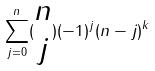Convert formula to latex. <formula><loc_0><loc_0><loc_500><loc_500>\sum _ { j = 0 } ^ { n } ( \begin{matrix} n \\ j \end{matrix} ) ( - 1 ) ^ { j } ( n - j ) ^ { k }</formula> 